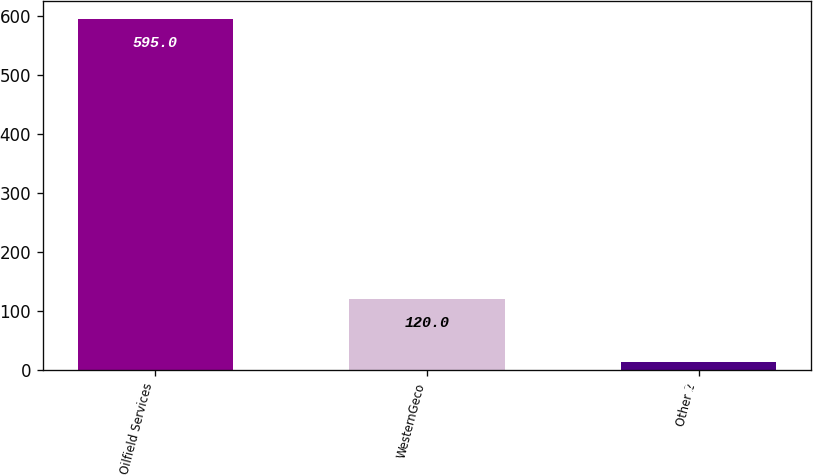<chart> <loc_0><loc_0><loc_500><loc_500><bar_chart><fcel>Oilfield Services<fcel>WesternGeco<fcel>Other 2<nl><fcel>595<fcel>120<fcel>13<nl></chart> 